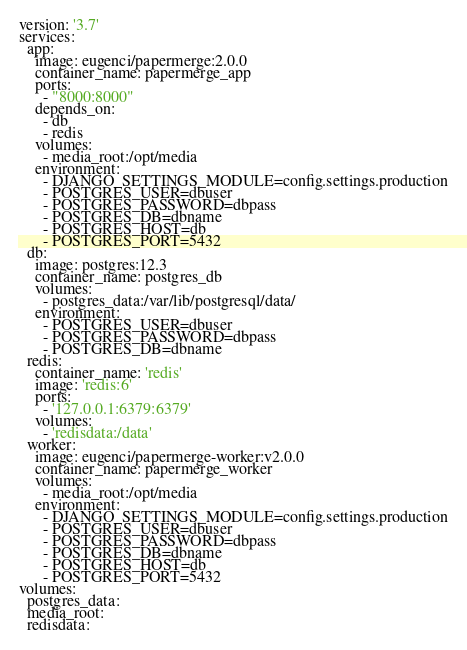Convert code to text. <code><loc_0><loc_0><loc_500><loc_500><_YAML_>version: '3.7'
services:
  app:
    image: eugenci/papermerge:2.0.0
    container_name: papermerge_app
    ports:
      - "8000:8000"
    depends_on:
      - db
      - redis
    volumes:
      - media_root:/opt/media
    environment:
      - DJANGO_SETTINGS_MODULE=config.settings.production
      - POSTGRES_USER=dbuser
      - POSTGRES_PASSWORD=dbpass
      - POSTGRES_DB=dbname
      - POSTGRES_HOST=db
      - POSTGRES_PORT=5432
  db:
    image: postgres:12.3
    container_name: postgres_db
    volumes:
      - postgres_data:/var/lib/postgresql/data/
    environment:
      - POSTGRES_USER=dbuser
      - POSTGRES_PASSWORD=dbpass
      - POSTGRES_DB=dbname
  redis:
    container_name: 'redis'
    image: 'redis:6'
    ports:
      - '127.0.0.1:6379:6379'
    volumes:
      - 'redisdata:/data'
  worker:
    image: eugenci/papermerge-worker:v2.0.0
    container_name: papermerge_worker
    volumes:
      - media_root:/opt/media
    environment:
      - DJANGO_SETTINGS_MODULE=config.settings.production
      - POSTGRES_USER=dbuser
      - POSTGRES_PASSWORD=dbpass
      - POSTGRES_DB=dbname
      - POSTGRES_HOST=db
      - POSTGRES_PORT=5432      
volumes:
  postgres_data:
  media_root:
  redisdata:
</code> 